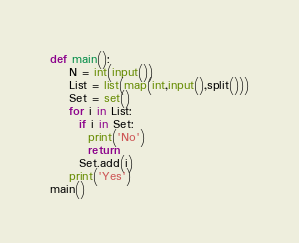Convert code to text. <code><loc_0><loc_0><loc_500><loc_500><_Python_>def main():
    N = int(input())
    List = list(map(int,input(),split()))
    Set = set()
    for i in List:
      if i in Set:
        print('No')
        return
      Set.add(i)
	print('Yes')
main()</code> 